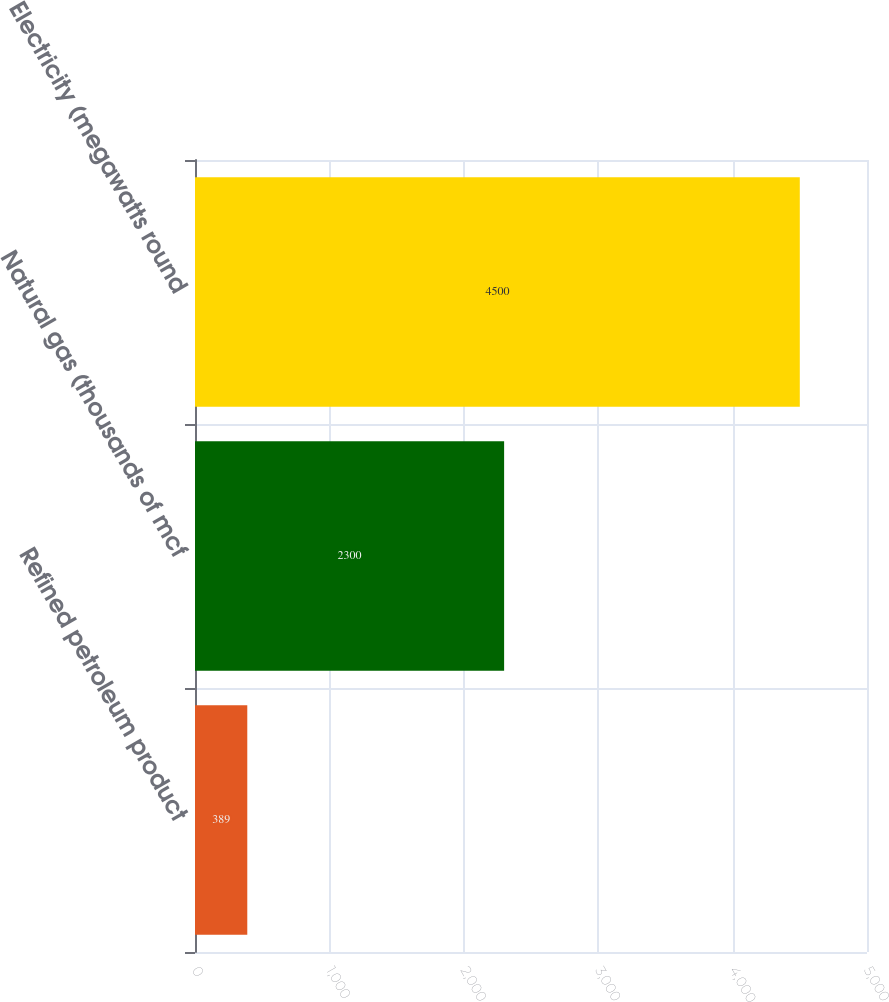<chart> <loc_0><loc_0><loc_500><loc_500><bar_chart><fcel>Refined petroleum product<fcel>Natural gas (thousands of mcf<fcel>Electricity (megawatts round<nl><fcel>389<fcel>2300<fcel>4500<nl></chart> 